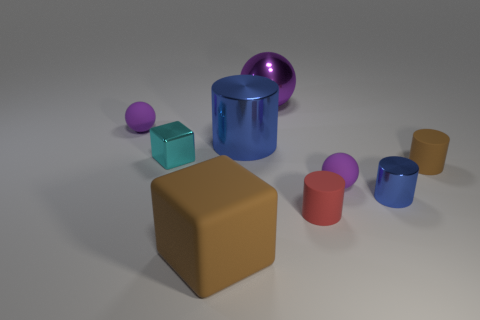Subtract all purple balls. How many were subtracted if there are2purple balls left? 1 Subtract all tiny spheres. How many spheres are left? 1 Subtract all cyan cubes. How many cubes are left? 1 Subtract all blocks. How many objects are left? 7 Subtract 2 spheres. How many spheres are left? 1 Subtract all blue spheres. Subtract all brown cubes. How many spheres are left? 3 Subtract all small cyan matte cylinders. Subtract all small cyan cubes. How many objects are left? 8 Add 7 tiny metal cubes. How many tiny metal cubes are left? 8 Add 7 small blue shiny cylinders. How many small blue shiny cylinders exist? 8 Subtract 0 cyan cylinders. How many objects are left? 9 